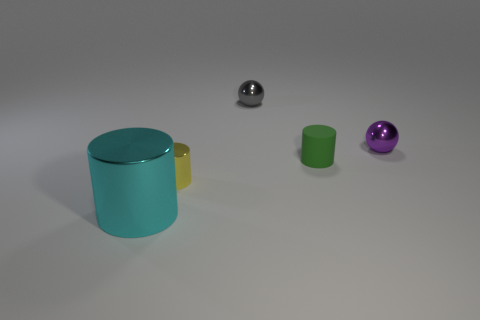Subtract all large cyan metal cylinders. How many cylinders are left? 2 Subtract all green cylinders. How many cylinders are left? 2 Subtract 2 cylinders. How many cylinders are left? 1 Subtract all cylinders. How many objects are left? 2 Add 1 large brown rubber objects. How many objects exist? 6 Subtract all blue cylinders. Subtract all gray balls. How many cylinders are left? 3 Subtract all yellow shiny objects. Subtract all cyan objects. How many objects are left? 3 Add 3 big cyan metal things. How many big cyan metal things are left? 4 Add 2 big metallic cylinders. How many big metallic cylinders exist? 3 Subtract 1 cyan cylinders. How many objects are left? 4 